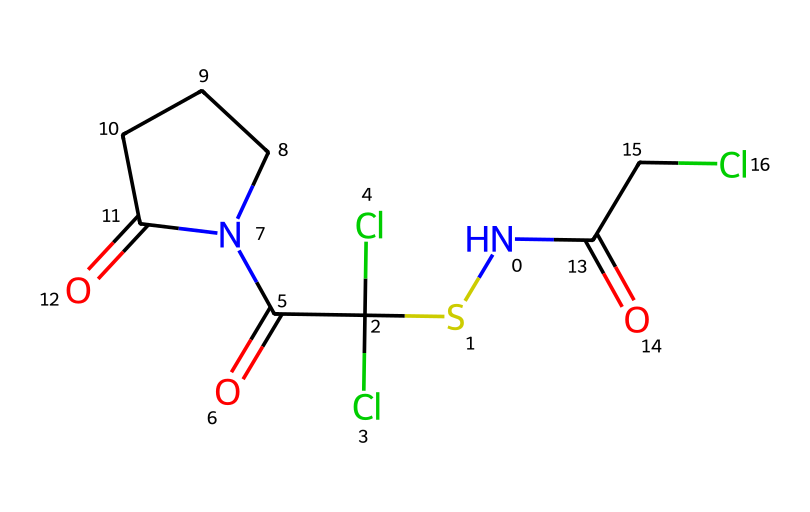How many chlorine atoms are present in captan? By examining the SMILES representation, we can identify the 'Cl' symbols which denote chlorine atoms. There are two instances of 'Cl' in the structure.
Answer: two What is the total number of nitrogen atoms in captan? The SMILES notation has 'N' symbols representing nitrogen atoms. In the provided structure, there is only one 'N'.
Answer: one What functional groups are present in captan? Looking at the SMILES, we can identify functional groups such as amide (C(=O)N) indicated by 'C(=O)N' and a thioether represented by 'S'.
Answer: amide, thioether Which part of captan contributes to its fungicidal properties? The sulfenamide part, characterized by the 'N(S...)' section in the SMILES, is typically responsible for interacting with fungal cells.
Answer: sulfenamide What is the molecular formula for captan? To derive the molecular formula, we count the individual atoms represented in the SMILES: C, H, Cl, N, O, and S. The total count leads to the formula C8H8Cl2N2O3S.
Answer: C8H8Cl2N2O3S How does the cyclic structure influence the properties of captan? The 'N1CCCC1' in the SMILES indicates a cyclic structure which can affect the stability, solubility, and reactivity of the compound due to steric strain and electronic effects.
Answer: cyclic structure influences stability and reactivity 